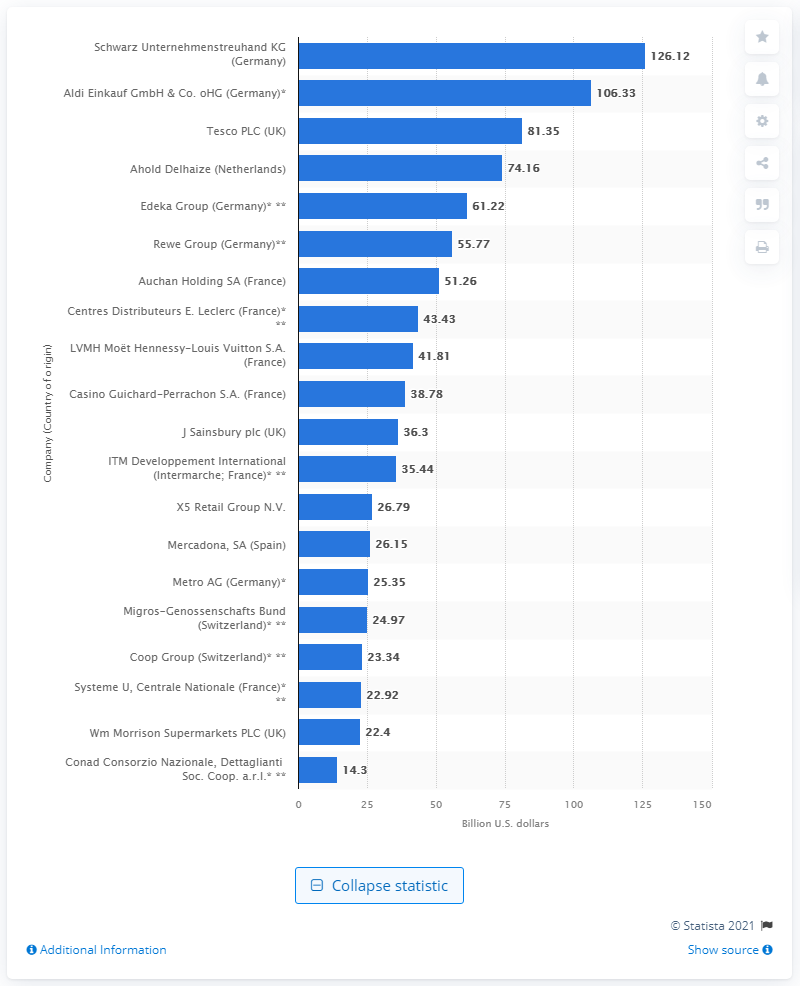Specify some key components in this picture. Aldi Einkauf GmbH & Ko. oHG generated a total revenue of 106.33.. in 2019. In 2019, the U.S. subsidiary of Schwarz Gruppe generated approximately $126.12 million in revenue. 